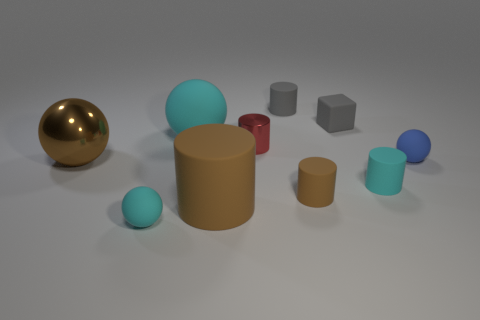Subtract all cubes. How many objects are left? 9 Subtract 0 blue cubes. How many objects are left? 10 Subtract all tiny red objects. Subtract all large cylinders. How many objects are left? 8 Add 1 gray cylinders. How many gray cylinders are left? 2 Add 9 large brown matte cylinders. How many large brown matte cylinders exist? 10 